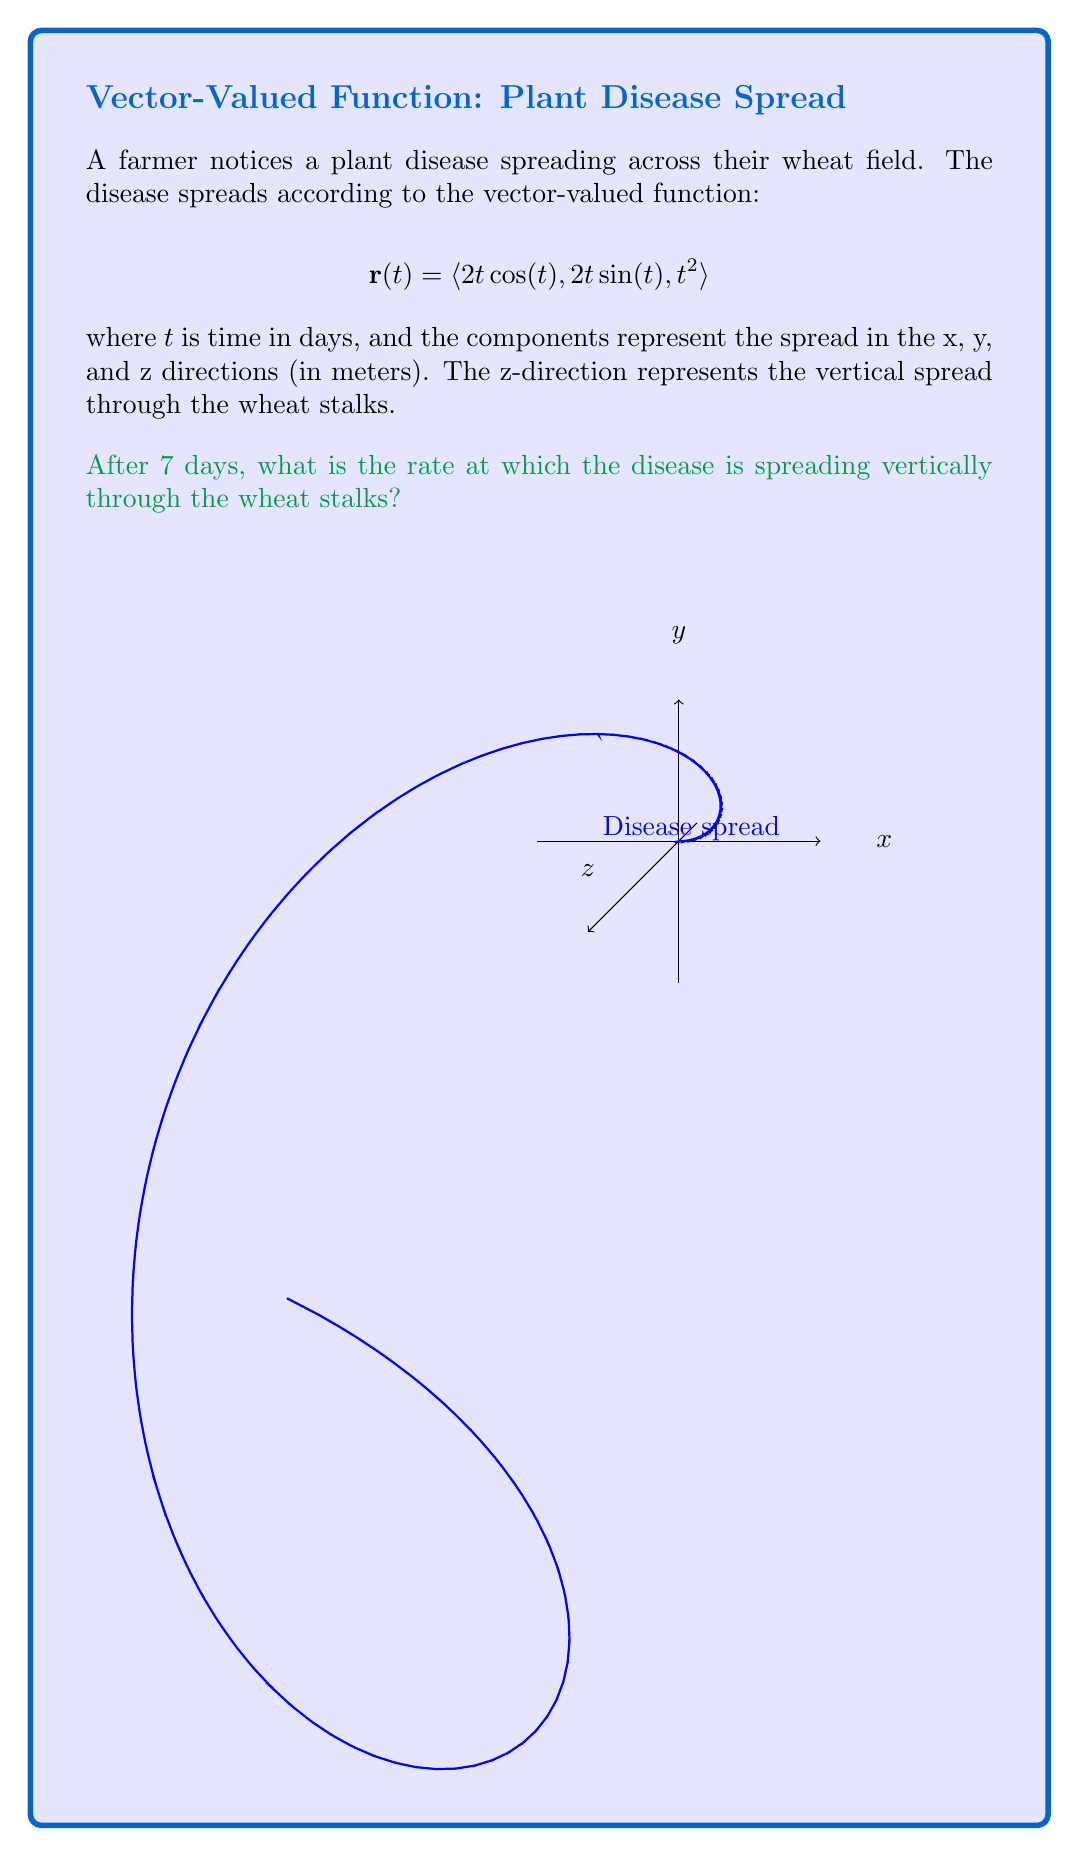What is the answer to this math problem? To solve this problem, we need to follow these steps:

1) The vector-valued function is given as:
   $$\mathbf{r}(t) = \langle 2t\cos(t), 2t\sin(t), t^2 \rangle$$

2) We need to find the rate of change in the z-direction (vertical spread) after 7 days. This is equivalent to finding the z-component of the velocity vector at t = 7.

3) To find the velocity vector, we need to differentiate $\mathbf{r}(t)$ with respect to t:
   
   $$\mathbf{v}(t) = \mathbf{r}'(t) = \langle 2\cos(t) - 2t\sin(t), 2\sin(t) + 2t\cos(t), 2t \rangle$$

4) The z-component of the velocity vector is $2t$.

5) We're asked about the rate after 7 days, so we need to evaluate this at t = 7:
   
   Vertical spread rate = $2t|_{t=7} = 2(7) = 14$ meters/day

Therefore, after 7 days, the disease is spreading vertically through the wheat stalks at a rate of 14 meters per day.
Answer: 14 meters/day 